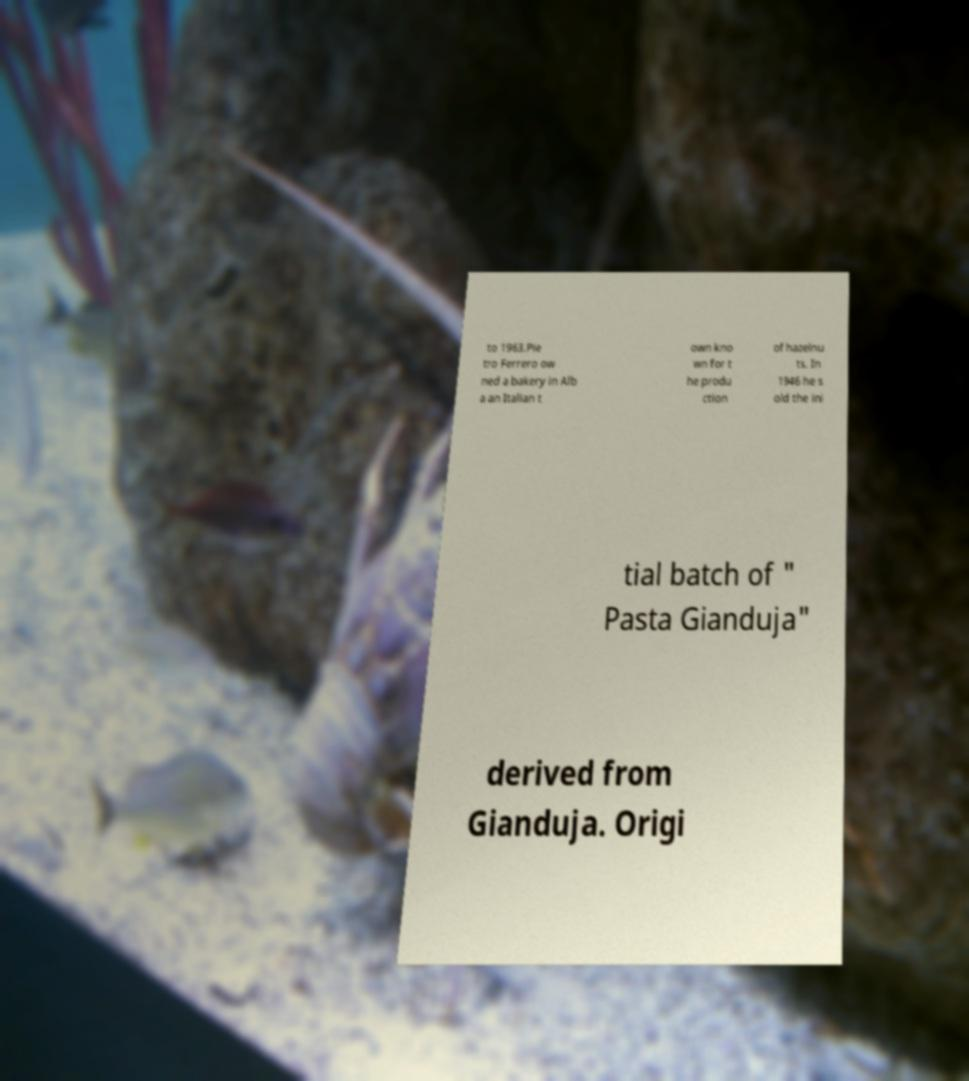There's text embedded in this image that I need extracted. Can you transcribe it verbatim? to 1963.Pie tro Ferrero ow ned a bakery in Alb a an Italian t own kno wn for t he produ ction of hazelnu ts. In 1946 he s old the ini tial batch of " Pasta Gianduja" derived from Gianduja. Origi 